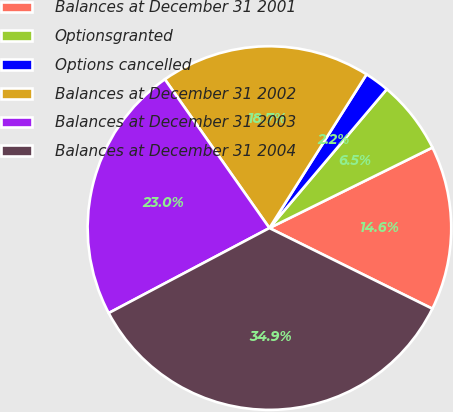Convert chart. <chart><loc_0><loc_0><loc_500><loc_500><pie_chart><fcel>Balances at December 31 2001<fcel>Optionsgranted<fcel>Options cancelled<fcel>Balances at December 31 2002<fcel>Balances at December 31 2003<fcel>Balances at December 31 2004<nl><fcel>14.62%<fcel>6.53%<fcel>2.2%<fcel>18.72%<fcel>22.99%<fcel>34.94%<nl></chart> 